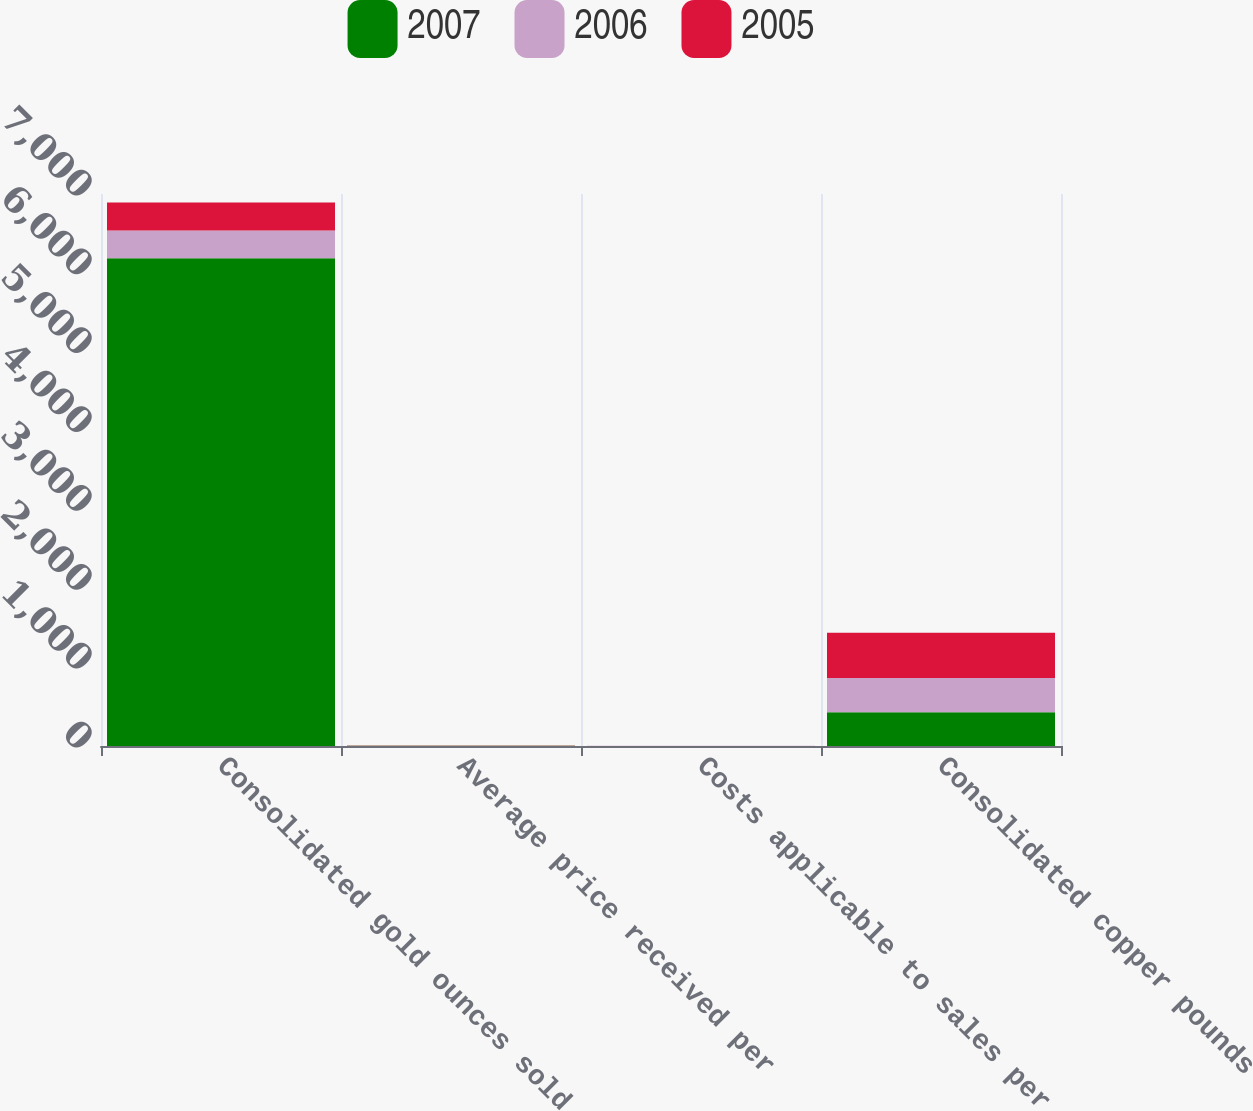Convert chart. <chart><loc_0><loc_0><loc_500><loc_500><stacked_bar_chart><ecel><fcel>Consolidated gold ounces sold<fcel>Average price received per<fcel>Costs applicable to sales per<fcel>Consolidated copper pounds<nl><fcel>2007<fcel>6184<fcel>2.86<fcel>1.1<fcel>428<nl><fcel>2006<fcel>354.5<fcel>1.54<fcel>0.71<fcel>435<nl><fcel>2005<fcel>354.5<fcel>1.17<fcel>0.53<fcel>573<nl></chart> 